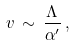Convert formula to latex. <formula><loc_0><loc_0><loc_500><loc_500>v \, \sim \, \frac { \Lambda } { \alpha ^ { \prime } } \, ,</formula> 